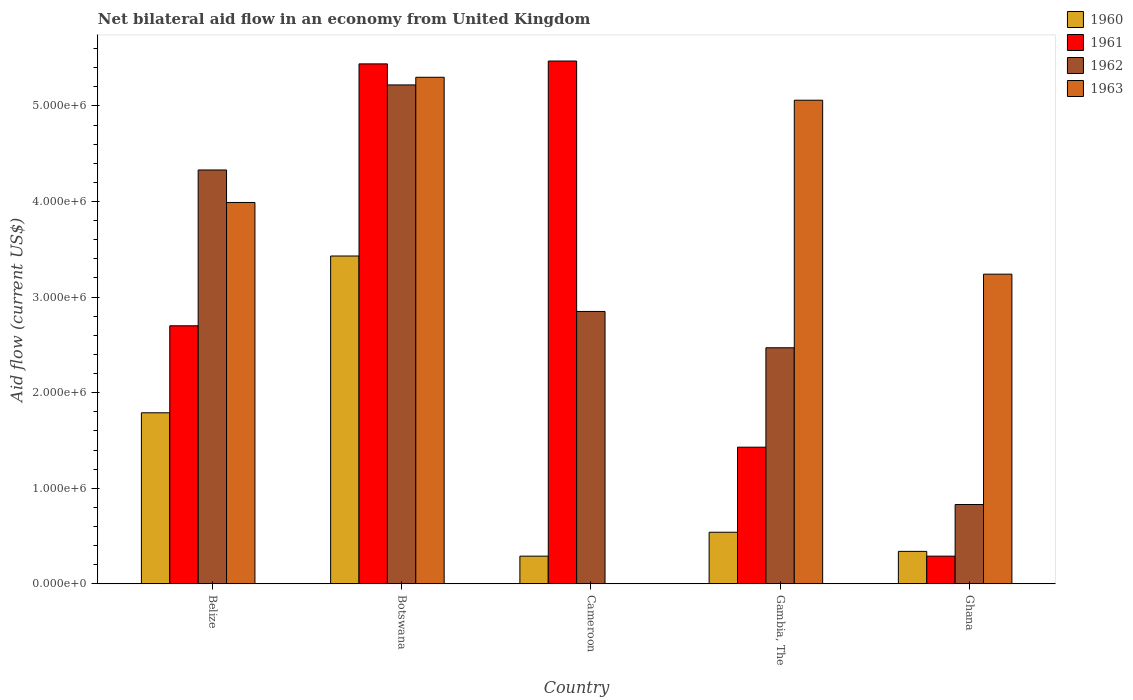How many different coloured bars are there?
Your answer should be compact. 4. How many bars are there on the 2nd tick from the left?
Offer a very short reply. 4. What is the label of the 2nd group of bars from the left?
Your response must be concise. Botswana. Across all countries, what is the maximum net bilateral aid flow in 1961?
Your answer should be very brief. 5.47e+06. Across all countries, what is the minimum net bilateral aid flow in 1961?
Make the answer very short. 2.90e+05. In which country was the net bilateral aid flow in 1963 maximum?
Your answer should be compact. Botswana. What is the total net bilateral aid flow in 1962 in the graph?
Provide a short and direct response. 1.57e+07. What is the difference between the net bilateral aid flow in 1960 in Belize and that in Ghana?
Your answer should be very brief. 1.45e+06. What is the difference between the net bilateral aid flow in 1963 in Gambia, The and the net bilateral aid flow in 1960 in Ghana?
Provide a short and direct response. 4.72e+06. What is the average net bilateral aid flow in 1963 per country?
Make the answer very short. 3.52e+06. What is the difference between the net bilateral aid flow of/in 1962 and net bilateral aid flow of/in 1963 in Gambia, The?
Make the answer very short. -2.59e+06. In how many countries, is the net bilateral aid flow in 1963 greater than 3000000 US$?
Give a very brief answer. 4. What is the ratio of the net bilateral aid flow in 1961 in Belize to that in Ghana?
Your response must be concise. 9.31. Is the difference between the net bilateral aid flow in 1962 in Botswana and Ghana greater than the difference between the net bilateral aid flow in 1963 in Botswana and Ghana?
Your response must be concise. Yes. What is the difference between the highest and the second highest net bilateral aid flow in 1961?
Your answer should be compact. 3.00e+04. What is the difference between the highest and the lowest net bilateral aid flow in 1963?
Offer a very short reply. 5.30e+06. In how many countries, is the net bilateral aid flow in 1960 greater than the average net bilateral aid flow in 1960 taken over all countries?
Your answer should be very brief. 2. Is it the case that in every country, the sum of the net bilateral aid flow in 1963 and net bilateral aid flow in 1961 is greater than the net bilateral aid flow in 1962?
Offer a very short reply. Yes. How many bars are there?
Give a very brief answer. 19. Are all the bars in the graph horizontal?
Provide a short and direct response. No. What is the difference between two consecutive major ticks on the Y-axis?
Your answer should be very brief. 1.00e+06. Where does the legend appear in the graph?
Your answer should be compact. Top right. How are the legend labels stacked?
Offer a terse response. Vertical. What is the title of the graph?
Give a very brief answer. Net bilateral aid flow in an economy from United Kingdom. Does "2009" appear as one of the legend labels in the graph?
Offer a terse response. No. What is the label or title of the X-axis?
Offer a very short reply. Country. What is the Aid flow (current US$) in 1960 in Belize?
Offer a terse response. 1.79e+06. What is the Aid flow (current US$) in 1961 in Belize?
Your answer should be compact. 2.70e+06. What is the Aid flow (current US$) in 1962 in Belize?
Provide a short and direct response. 4.33e+06. What is the Aid flow (current US$) of 1963 in Belize?
Make the answer very short. 3.99e+06. What is the Aid flow (current US$) of 1960 in Botswana?
Your answer should be very brief. 3.43e+06. What is the Aid flow (current US$) in 1961 in Botswana?
Make the answer very short. 5.44e+06. What is the Aid flow (current US$) of 1962 in Botswana?
Make the answer very short. 5.22e+06. What is the Aid flow (current US$) of 1963 in Botswana?
Provide a succinct answer. 5.30e+06. What is the Aid flow (current US$) of 1960 in Cameroon?
Make the answer very short. 2.90e+05. What is the Aid flow (current US$) in 1961 in Cameroon?
Your answer should be very brief. 5.47e+06. What is the Aid flow (current US$) in 1962 in Cameroon?
Offer a very short reply. 2.85e+06. What is the Aid flow (current US$) of 1960 in Gambia, The?
Give a very brief answer. 5.40e+05. What is the Aid flow (current US$) of 1961 in Gambia, The?
Offer a terse response. 1.43e+06. What is the Aid flow (current US$) of 1962 in Gambia, The?
Your answer should be very brief. 2.47e+06. What is the Aid flow (current US$) of 1963 in Gambia, The?
Keep it short and to the point. 5.06e+06. What is the Aid flow (current US$) of 1960 in Ghana?
Your answer should be compact. 3.40e+05. What is the Aid flow (current US$) in 1961 in Ghana?
Your answer should be very brief. 2.90e+05. What is the Aid flow (current US$) of 1962 in Ghana?
Keep it short and to the point. 8.30e+05. What is the Aid flow (current US$) of 1963 in Ghana?
Your response must be concise. 3.24e+06. Across all countries, what is the maximum Aid flow (current US$) of 1960?
Offer a terse response. 3.43e+06. Across all countries, what is the maximum Aid flow (current US$) in 1961?
Offer a terse response. 5.47e+06. Across all countries, what is the maximum Aid flow (current US$) of 1962?
Give a very brief answer. 5.22e+06. Across all countries, what is the maximum Aid flow (current US$) in 1963?
Provide a succinct answer. 5.30e+06. Across all countries, what is the minimum Aid flow (current US$) of 1960?
Your response must be concise. 2.90e+05. Across all countries, what is the minimum Aid flow (current US$) of 1962?
Your response must be concise. 8.30e+05. What is the total Aid flow (current US$) in 1960 in the graph?
Your answer should be compact. 6.39e+06. What is the total Aid flow (current US$) in 1961 in the graph?
Offer a very short reply. 1.53e+07. What is the total Aid flow (current US$) of 1962 in the graph?
Keep it short and to the point. 1.57e+07. What is the total Aid flow (current US$) in 1963 in the graph?
Make the answer very short. 1.76e+07. What is the difference between the Aid flow (current US$) in 1960 in Belize and that in Botswana?
Offer a terse response. -1.64e+06. What is the difference between the Aid flow (current US$) of 1961 in Belize and that in Botswana?
Ensure brevity in your answer.  -2.74e+06. What is the difference between the Aid flow (current US$) in 1962 in Belize and that in Botswana?
Make the answer very short. -8.90e+05. What is the difference between the Aid flow (current US$) in 1963 in Belize and that in Botswana?
Offer a very short reply. -1.31e+06. What is the difference between the Aid flow (current US$) in 1960 in Belize and that in Cameroon?
Offer a very short reply. 1.50e+06. What is the difference between the Aid flow (current US$) of 1961 in Belize and that in Cameroon?
Offer a terse response. -2.77e+06. What is the difference between the Aid flow (current US$) in 1962 in Belize and that in Cameroon?
Offer a very short reply. 1.48e+06. What is the difference between the Aid flow (current US$) in 1960 in Belize and that in Gambia, The?
Provide a short and direct response. 1.25e+06. What is the difference between the Aid flow (current US$) in 1961 in Belize and that in Gambia, The?
Give a very brief answer. 1.27e+06. What is the difference between the Aid flow (current US$) in 1962 in Belize and that in Gambia, The?
Offer a terse response. 1.86e+06. What is the difference between the Aid flow (current US$) in 1963 in Belize and that in Gambia, The?
Your answer should be compact. -1.07e+06. What is the difference between the Aid flow (current US$) in 1960 in Belize and that in Ghana?
Offer a very short reply. 1.45e+06. What is the difference between the Aid flow (current US$) in 1961 in Belize and that in Ghana?
Ensure brevity in your answer.  2.41e+06. What is the difference between the Aid flow (current US$) in 1962 in Belize and that in Ghana?
Offer a terse response. 3.50e+06. What is the difference between the Aid flow (current US$) of 1963 in Belize and that in Ghana?
Offer a terse response. 7.50e+05. What is the difference between the Aid flow (current US$) of 1960 in Botswana and that in Cameroon?
Your response must be concise. 3.14e+06. What is the difference between the Aid flow (current US$) in 1962 in Botswana and that in Cameroon?
Your answer should be very brief. 2.37e+06. What is the difference between the Aid flow (current US$) of 1960 in Botswana and that in Gambia, The?
Offer a terse response. 2.89e+06. What is the difference between the Aid flow (current US$) in 1961 in Botswana and that in Gambia, The?
Offer a very short reply. 4.01e+06. What is the difference between the Aid flow (current US$) in 1962 in Botswana and that in Gambia, The?
Your response must be concise. 2.75e+06. What is the difference between the Aid flow (current US$) of 1963 in Botswana and that in Gambia, The?
Give a very brief answer. 2.40e+05. What is the difference between the Aid flow (current US$) in 1960 in Botswana and that in Ghana?
Keep it short and to the point. 3.09e+06. What is the difference between the Aid flow (current US$) in 1961 in Botswana and that in Ghana?
Give a very brief answer. 5.15e+06. What is the difference between the Aid flow (current US$) in 1962 in Botswana and that in Ghana?
Your answer should be compact. 4.39e+06. What is the difference between the Aid flow (current US$) in 1963 in Botswana and that in Ghana?
Give a very brief answer. 2.06e+06. What is the difference between the Aid flow (current US$) of 1960 in Cameroon and that in Gambia, The?
Your answer should be very brief. -2.50e+05. What is the difference between the Aid flow (current US$) of 1961 in Cameroon and that in Gambia, The?
Provide a short and direct response. 4.04e+06. What is the difference between the Aid flow (current US$) of 1960 in Cameroon and that in Ghana?
Offer a terse response. -5.00e+04. What is the difference between the Aid flow (current US$) of 1961 in Cameroon and that in Ghana?
Give a very brief answer. 5.18e+06. What is the difference between the Aid flow (current US$) in 1962 in Cameroon and that in Ghana?
Your response must be concise. 2.02e+06. What is the difference between the Aid flow (current US$) in 1961 in Gambia, The and that in Ghana?
Make the answer very short. 1.14e+06. What is the difference between the Aid flow (current US$) in 1962 in Gambia, The and that in Ghana?
Keep it short and to the point. 1.64e+06. What is the difference between the Aid flow (current US$) in 1963 in Gambia, The and that in Ghana?
Ensure brevity in your answer.  1.82e+06. What is the difference between the Aid flow (current US$) of 1960 in Belize and the Aid flow (current US$) of 1961 in Botswana?
Ensure brevity in your answer.  -3.65e+06. What is the difference between the Aid flow (current US$) in 1960 in Belize and the Aid flow (current US$) in 1962 in Botswana?
Offer a very short reply. -3.43e+06. What is the difference between the Aid flow (current US$) in 1960 in Belize and the Aid flow (current US$) in 1963 in Botswana?
Provide a succinct answer. -3.51e+06. What is the difference between the Aid flow (current US$) in 1961 in Belize and the Aid flow (current US$) in 1962 in Botswana?
Make the answer very short. -2.52e+06. What is the difference between the Aid flow (current US$) in 1961 in Belize and the Aid flow (current US$) in 1963 in Botswana?
Your answer should be very brief. -2.60e+06. What is the difference between the Aid flow (current US$) of 1962 in Belize and the Aid flow (current US$) of 1963 in Botswana?
Your answer should be very brief. -9.70e+05. What is the difference between the Aid flow (current US$) of 1960 in Belize and the Aid flow (current US$) of 1961 in Cameroon?
Ensure brevity in your answer.  -3.68e+06. What is the difference between the Aid flow (current US$) in 1960 in Belize and the Aid flow (current US$) in 1962 in Cameroon?
Your answer should be compact. -1.06e+06. What is the difference between the Aid flow (current US$) in 1960 in Belize and the Aid flow (current US$) in 1962 in Gambia, The?
Provide a short and direct response. -6.80e+05. What is the difference between the Aid flow (current US$) of 1960 in Belize and the Aid flow (current US$) of 1963 in Gambia, The?
Give a very brief answer. -3.27e+06. What is the difference between the Aid flow (current US$) in 1961 in Belize and the Aid flow (current US$) in 1962 in Gambia, The?
Make the answer very short. 2.30e+05. What is the difference between the Aid flow (current US$) in 1961 in Belize and the Aid flow (current US$) in 1963 in Gambia, The?
Provide a short and direct response. -2.36e+06. What is the difference between the Aid flow (current US$) of 1962 in Belize and the Aid flow (current US$) of 1963 in Gambia, The?
Your answer should be compact. -7.30e+05. What is the difference between the Aid flow (current US$) of 1960 in Belize and the Aid flow (current US$) of 1961 in Ghana?
Make the answer very short. 1.50e+06. What is the difference between the Aid flow (current US$) of 1960 in Belize and the Aid flow (current US$) of 1962 in Ghana?
Your answer should be compact. 9.60e+05. What is the difference between the Aid flow (current US$) in 1960 in Belize and the Aid flow (current US$) in 1963 in Ghana?
Keep it short and to the point. -1.45e+06. What is the difference between the Aid flow (current US$) of 1961 in Belize and the Aid flow (current US$) of 1962 in Ghana?
Give a very brief answer. 1.87e+06. What is the difference between the Aid flow (current US$) in 1961 in Belize and the Aid flow (current US$) in 1963 in Ghana?
Provide a succinct answer. -5.40e+05. What is the difference between the Aid flow (current US$) in 1962 in Belize and the Aid flow (current US$) in 1963 in Ghana?
Offer a very short reply. 1.09e+06. What is the difference between the Aid flow (current US$) of 1960 in Botswana and the Aid flow (current US$) of 1961 in Cameroon?
Your response must be concise. -2.04e+06. What is the difference between the Aid flow (current US$) of 1960 in Botswana and the Aid flow (current US$) of 1962 in Cameroon?
Your answer should be very brief. 5.80e+05. What is the difference between the Aid flow (current US$) of 1961 in Botswana and the Aid flow (current US$) of 1962 in Cameroon?
Ensure brevity in your answer.  2.59e+06. What is the difference between the Aid flow (current US$) in 1960 in Botswana and the Aid flow (current US$) in 1961 in Gambia, The?
Make the answer very short. 2.00e+06. What is the difference between the Aid flow (current US$) in 1960 in Botswana and the Aid flow (current US$) in 1962 in Gambia, The?
Ensure brevity in your answer.  9.60e+05. What is the difference between the Aid flow (current US$) of 1960 in Botswana and the Aid flow (current US$) of 1963 in Gambia, The?
Ensure brevity in your answer.  -1.63e+06. What is the difference between the Aid flow (current US$) of 1961 in Botswana and the Aid flow (current US$) of 1962 in Gambia, The?
Offer a very short reply. 2.97e+06. What is the difference between the Aid flow (current US$) of 1960 in Botswana and the Aid flow (current US$) of 1961 in Ghana?
Your answer should be compact. 3.14e+06. What is the difference between the Aid flow (current US$) in 1960 in Botswana and the Aid flow (current US$) in 1962 in Ghana?
Make the answer very short. 2.60e+06. What is the difference between the Aid flow (current US$) of 1961 in Botswana and the Aid flow (current US$) of 1962 in Ghana?
Your answer should be very brief. 4.61e+06. What is the difference between the Aid flow (current US$) in 1961 in Botswana and the Aid flow (current US$) in 1963 in Ghana?
Offer a terse response. 2.20e+06. What is the difference between the Aid flow (current US$) of 1962 in Botswana and the Aid flow (current US$) of 1963 in Ghana?
Your answer should be compact. 1.98e+06. What is the difference between the Aid flow (current US$) in 1960 in Cameroon and the Aid flow (current US$) in 1961 in Gambia, The?
Offer a very short reply. -1.14e+06. What is the difference between the Aid flow (current US$) in 1960 in Cameroon and the Aid flow (current US$) in 1962 in Gambia, The?
Make the answer very short. -2.18e+06. What is the difference between the Aid flow (current US$) of 1960 in Cameroon and the Aid flow (current US$) of 1963 in Gambia, The?
Your response must be concise. -4.77e+06. What is the difference between the Aid flow (current US$) in 1961 in Cameroon and the Aid flow (current US$) in 1962 in Gambia, The?
Offer a very short reply. 3.00e+06. What is the difference between the Aid flow (current US$) of 1962 in Cameroon and the Aid flow (current US$) of 1963 in Gambia, The?
Give a very brief answer. -2.21e+06. What is the difference between the Aid flow (current US$) in 1960 in Cameroon and the Aid flow (current US$) in 1962 in Ghana?
Offer a very short reply. -5.40e+05. What is the difference between the Aid flow (current US$) in 1960 in Cameroon and the Aid flow (current US$) in 1963 in Ghana?
Provide a succinct answer. -2.95e+06. What is the difference between the Aid flow (current US$) in 1961 in Cameroon and the Aid flow (current US$) in 1962 in Ghana?
Your answer should be very brief. 4.64e+06. What is the difference between the Aid flow (current US$) of 1961 in Cameroon and the Aid flow (current US$) of 1963 in Ghana?
Make the answer very short. 2.23e+06. What is the difference between the Aid flow (current US$) in 1962 in Cameroon and the Aid flow (current US$) in 1963 in Ghana?
Provide a succinct answer. -3.90e+05. What is the difference between the Aid flow (current US$) in 1960 in Gambia, The and the Aid flow (current US$) in 1963 in Ghana?
Provide a short and direct response. -2.70e+06. What is the difference between the Aid flow (current US$) in 1961 in Gambia, The and the Aid flow (current US$) in 1962 in Ghana?
Provide a succinct answer. 6.00e+05. What is the difference between the Aid flow (current US$) of 1961 in Gambia, The and the Aid flow (current US$) of 1963 in Ghana?
Make the answer very short. -1.81e+06. What is the difference between the Aid flow (current US$) in 1962 in Gambia, The and the Aid flow (current US$) in 1963 in Ghana?
Give a very brief answer. -7.70e+05. What is the average Aid flow (current US$) of 1960 per country?
Keep it short and to the point. 1.28e+06. What is the average Aid flow (current US$) in 1961 per country?
Your answer should be very brief. 3.07e+06. What is the average Aid flow (current US$) in 1962 per country?
Provide a short and direct response. 3.14e+06. What is the average Aid flow (current US$) in 1963 per country?
Ensure brevity in your answer.  3.52e+06. What is the difference between the Aid flow (current US$) of 1960 and Aid flow (current US$) of 1961 in Belize?
Provide a succinct answer. -9.10e+05. What is the difference between the Aid flow (current US$) of 1960 and Aid flow (current US$) of 1962 in Belize?
Ensure brevity in your answer.  -2.54e+06. What is the difference between the Aid flow (current US$) of 1960 and Aid flow (current US$) of 1963 in Belize?
Provide a short and direct response. -2.20e+06. What is the difference between the Aid flow (current US$) in 1961 and Aid flow (current US$) in 1962 in Belize?
Give a very brief answer. -1.63e+06. What is the difference between the Aid flow (current US$) of 1961 and Aid flow (current US$) of 1963 in Belize?
Give a very brief answer. -1.29e+06. What is the difference between the Aid flow (current US$) of 1960 and Aid flow (current US$) of 1961 in Botswana?
Give a very brief answer. -2.01e+06. What is the difference between the Aid flow (current US$) in 1960 and Aid flow (current US$) in 1962 in Botswana?
Give a very brief answer. -1.79e+06. What is the difference between the Aid flow (current US$) of 1960 and Aid flow (current US$) of 1963 in Botswana?
Your answer should be very brief. -1.87e+06. What is the difference between the Aid flow (current US$) of 1960 and Aid flow (current US$) of 1961 in Cameroon?
Offer a very short reply. -5.18e+06. What is the difference between the Aid flow (current US$) of 1960 and Aid flow (current US$) of 1962 in Cameroon?
Give a very brief answer. -2.56e+06. What is the difference between the Aid flow (current US$) of 1961 and Aid flow (current US$) of 1962 in Cameroon?
Your answer should be very brief. 2.62e+06. What is the difference between the Aid flow (current US$) of 1960 and Aid flow (current US$) of 1961 in Gambia, The?
Ensure brevity in your answer.  -8.90e+05. What is the difference between the Aid flow (current US$) in 1960 and Aid flow (current US$) in 1962 in Gambia, The?
Your answer should be compact. -1.93e+06. What is the difference between the Aid flow (current US$) in 1960 and Aid flow (current US$) in 1963 in Gambia, The?
Provide a short and direct response. -4.52e+06. What is the difference between the Aid flow (current US$) of 1961 and Aid flow (current US$) of 1962 in Gambia, The?
Give a very brief answer. -1.04e+06. What is the difference between the Aid flow (current US$) of 1961 and Aid flow (current US$) of 1963 in Gambia, The?
Offer a very short reply. -3.63e+06. What is the difference between the Aid flow (current US$) of 1962 and Aid flow (current US$) of 1963 in Gambia, The?
Make the answer very short. -2.59e+06. What is the difference between the Aid flow (current US$) in 1960 and Aid flow (current US$) in 1961 in Ghana?
Provide a short and direct response. 5.00e+04. What is the difference between the Aid flow (current US$) of 1960 and Aid flow (current US$) of 1962 in Ghana?
Give a very brief answer. -4.90e+05. What is the difference between the Aid flow (current US$) of 1960 and Aid flow (current US$) of 1963 in Ghana?
Provide a short and direct response. -2.90e+06. What is the difference between the Aid flow (current US$) in 1961 and Aid flow (current US$) in 1962 in Ghana?
Ensure brevity in your answer.  -5.40e+05. What is the difference between the Aid flow (current US$) in 1961 and Aid flow (current US$) in 1963 in Ghana?
Your answer should be very brief. -2.95e+06. What is the difference between the Aid flow (current US$) in 1962 and Aid flow (current US$) in 1963 in Ghana?
Your response must be concise. -2.41e+06. What is the ratio of the Aid flow (current US$) in 1960 in Belize to that in Botswana?
Offer a very short reply. 0.52. What is the ratio of the Aid flow (current US$) of 1961 in Belize to that in Botswana?
Ensure brevity in your answer.  0.5. What is the ratio of the Aid flow (current US$) in 1962 in Belize to that in Botswana?
Give a very brief answer. 0.83. What is the ratio of the Aid flow (current US$) of 1963 in Belize to that in Botswana?
Your answer should be very brief. 0.75. What is the ratio of the Aid flow (current US$) in 1960 in Belize to that in Cameroon?
Offer a very short reply. 6.17. What is the ratio of the Aid flow (current US$) in 1961 in Belize to that in Cameroon?
Give a very brief answer. 0.49. What is the ratio of the Aid flow (current US$) of 1962 in Belize to that in Cameroon?
Ensure brevity in your answer.  1.52. What is the ratio of the Aid flow (current US$) of 1960 in Belize to that in Gambia, The?
Provide a succinct answer. 3.31. What is the ratio of the Aid flow (current US$) of 1961 in Belize to that in Gambia, The?
Your answer should be very brief. 1.89. What is the ratio of the Aid flow (current US$) in 1962 in Belize to that in Gambia, The?
Keep it short and to the point. 1.75. What is the ratio of the Aid flow (current US$) of 1963 in Belize to that in Gambia, The?
Your response must be concise. 0.79. What is the ratio of the Aid flow (current US$) in 1960 in Belize to that in Ghana?
Your answer should be compact. 5.26. What is the ratio of the Aid flow (current US$) of 1961 in Belize to that in Ghana?
Ensure brevity in your answer.  9.31. What is the ratio of the Aid flow (current US$) in 1962 in Belize to that in Ghana?
Offer a very short reply. 5.22. What is the ratio of the Aid flow (current US$) of 1963 in Belize to that in Ghana?
Your answer should be very brief. 1.23. What is the ratio of the Aid flow (current US$) of 1960 in Botswana to that in Cameroon?
Your answer should be compact. 11.83. What is the ratio of the Aid flow (current US$) in 1961 in Botswana to that in Cameroon?
Provide a succinct answer. 0.99. What is the ratio of the Aid flow (current US$) of 1962 in Botswana to that in Cameroon?
Provide a short and direct response. 1.83. What is the ratio of the Aid flow (current US$) in 1960 in Botswana to that in Gambia, The?
Ensure brevity in your answer.  6.35. What is the ratio of the Aid flow (current US$) in 1961 in Botswana to that in Gambia, The?
Your answer should be compact. 3.8. What is the ratio of the Aid flow (current US$) of 1962 in Botswana to that in Gambia, The?
Your response must be concise. 2.11. What is the ratio of the Aid flow (current US$) in 1963 in Botswana to that in Gambia, The?
Offer a very short reply. 1.05. What is the ratio of the Aid flow (current US$) in 1960 in Botswana to that in Ghana?
Provide a short and direct response. 10.09. What is the ratio of the Aid flow (current US$) of 1961 in Botswana to that in Ghana?
Give a very brief answer. 18.76. What is the ratio of the Aid flow (current US$) of 1962 in Botswana to that in Ghana?
Ensure brevity in your answer.  6.29. What is the ratio of the Aid flow (current US$) of 1963 in Botswana to that in Ghana?
Provide a short and direct response. 1.64. What is the ratio of the Aid flow (current US$) in 1960 in Cameroon to that in Gambia, The?
Your response must be concise. 0.54. What is the ratio of the Aid flow (current US$) in 1961 in Cameroon to that in Gambia, The?
Keep it short and to the point. 3.83. What is the ratio of the Aid flow (current US$) in 1962 in Cameroon to that in Gambia, The?
Ensure brevity in your answer.  1.15. What is the ratio of the Aid flow (current US$) in 1960 in Cameroon to that in Ghana?
Offer a terse response. 0.85. What is the ratio of the Aid flow (current US$) in 1961 in Cameroon to that in Ghana?
Your response must be concise. 18.86. What is the ratio of the Aid flow (current US$) of 1962 in Cameroon to that in Ghana?
Offer a very short reply. 3.43. What is the ratio of the Aid flow (current US$) in 1960 in Gambia, The to that in Ghana?
Your response must be concise. 1.59. What is the ratio of the Aid flow (current US$) in 1961 in Gambia, The to that in Ghana?
Provide a succinct answer. 4.93. What is the ratio of the Aid flow (current US$) in 1962 in Gambia, The to that in Ghana?
Provide a short and direct response. 2.98. What is the ratio of the Aid flow (current US$) in 1963 in Gambia, The to that in Ghana?
Offer a terse response. 1.56. What is the difference between the highest and the second highest Aid flow (current US$) in 1960?
Provide a succinct answer. 1.64e+06. What is the difference between the highest and the second highest Aid flow (current US$) in 1961?
Ensure brevity in your answer.  3.00e+04. What is the difference between the highest and the second highest Aid flow (current US$) in 1962?
Your answer should be very brief. 8.90e+05. What is the difference between the highest and the second highest Aid flow (current US$) of 1963?
Offer a very short reply. 2.40e+05. What is the difference between the highest and the lowest Aid flow (current US$) of 1960?
Your response must be concise. 3.14e+06. What is the difference between the highest and the lowest Aid flow (current US$) in 1961?
Provide a succinct answer. 5.18e+06. What is the difference between the highest and the lowest Aid flow (current US$) in 1962?
Ensure brevity in your answer.  4.39e+06. What is the difference between the highest and the lowest Aid flow (current US$) in 1963?
Offer a terse response. 5.30e+06. 